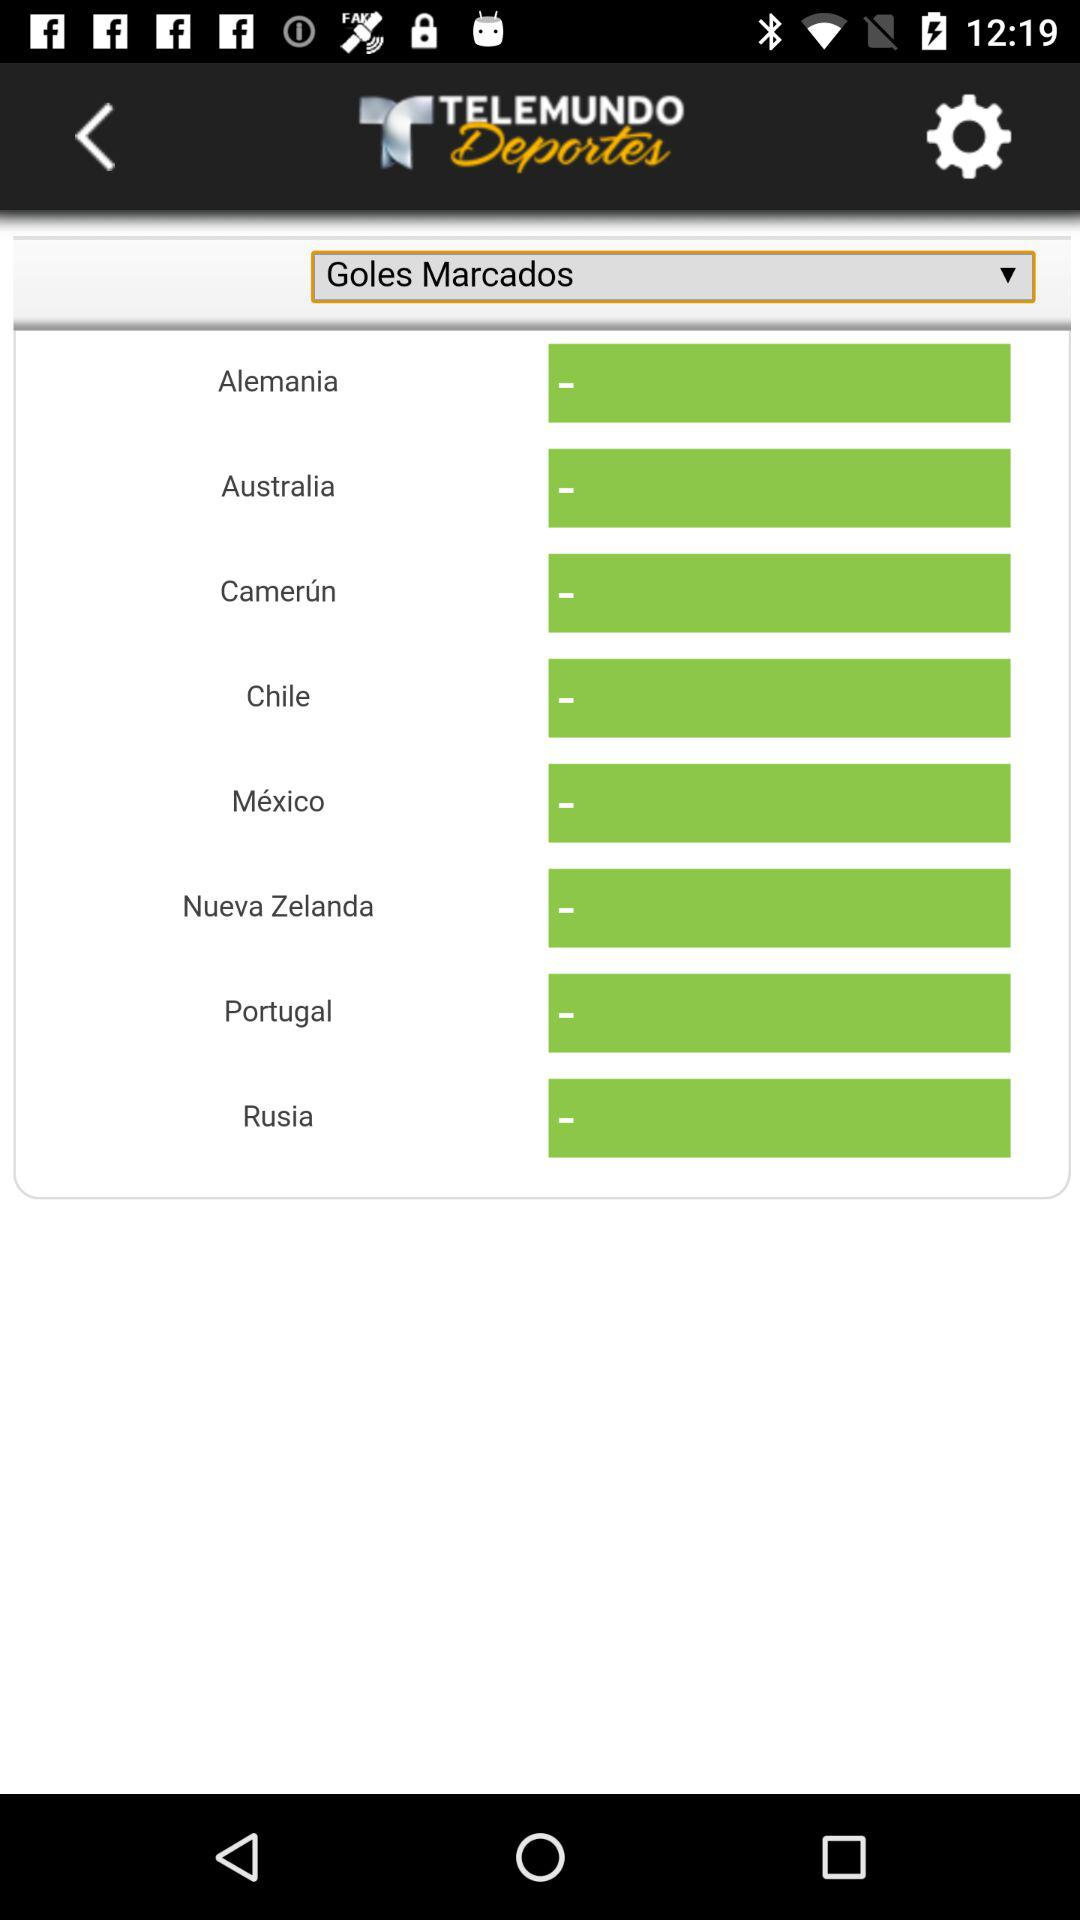What is the application name? The application name is "TELEMUNDO Deportes". 